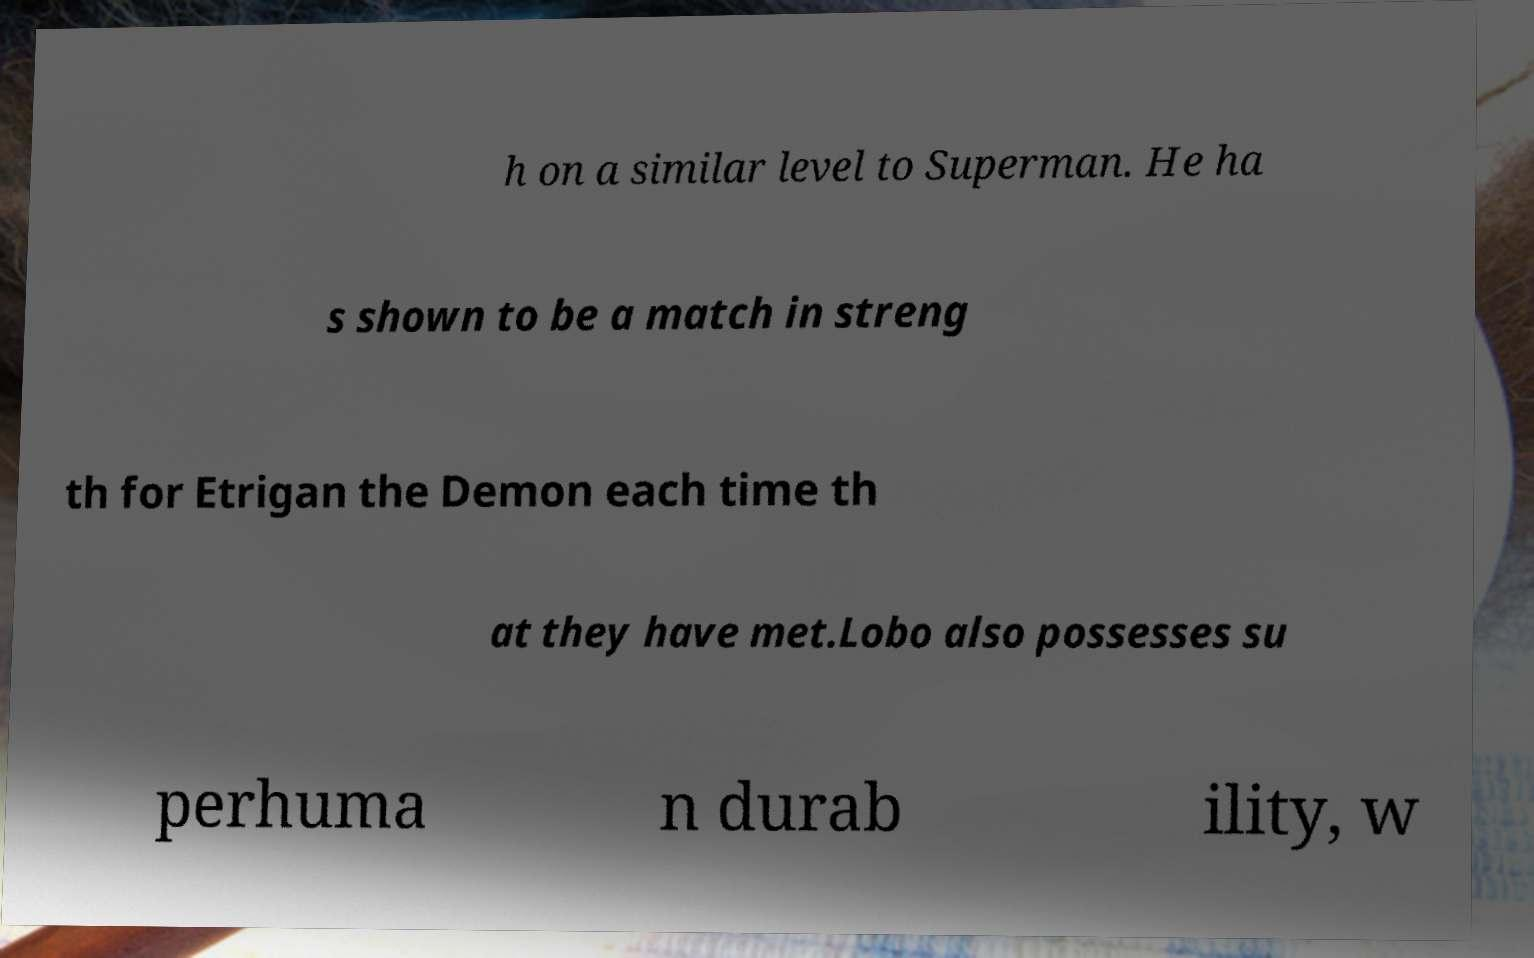What messages or text are displayed in this image? I need them in a readable, typed format. h on a similar level to Superman. He ha s shown to be a match in streng th for Etrigan the Demon each time th at they have met.Lobo also possesses su perhuma n durab ility, w 